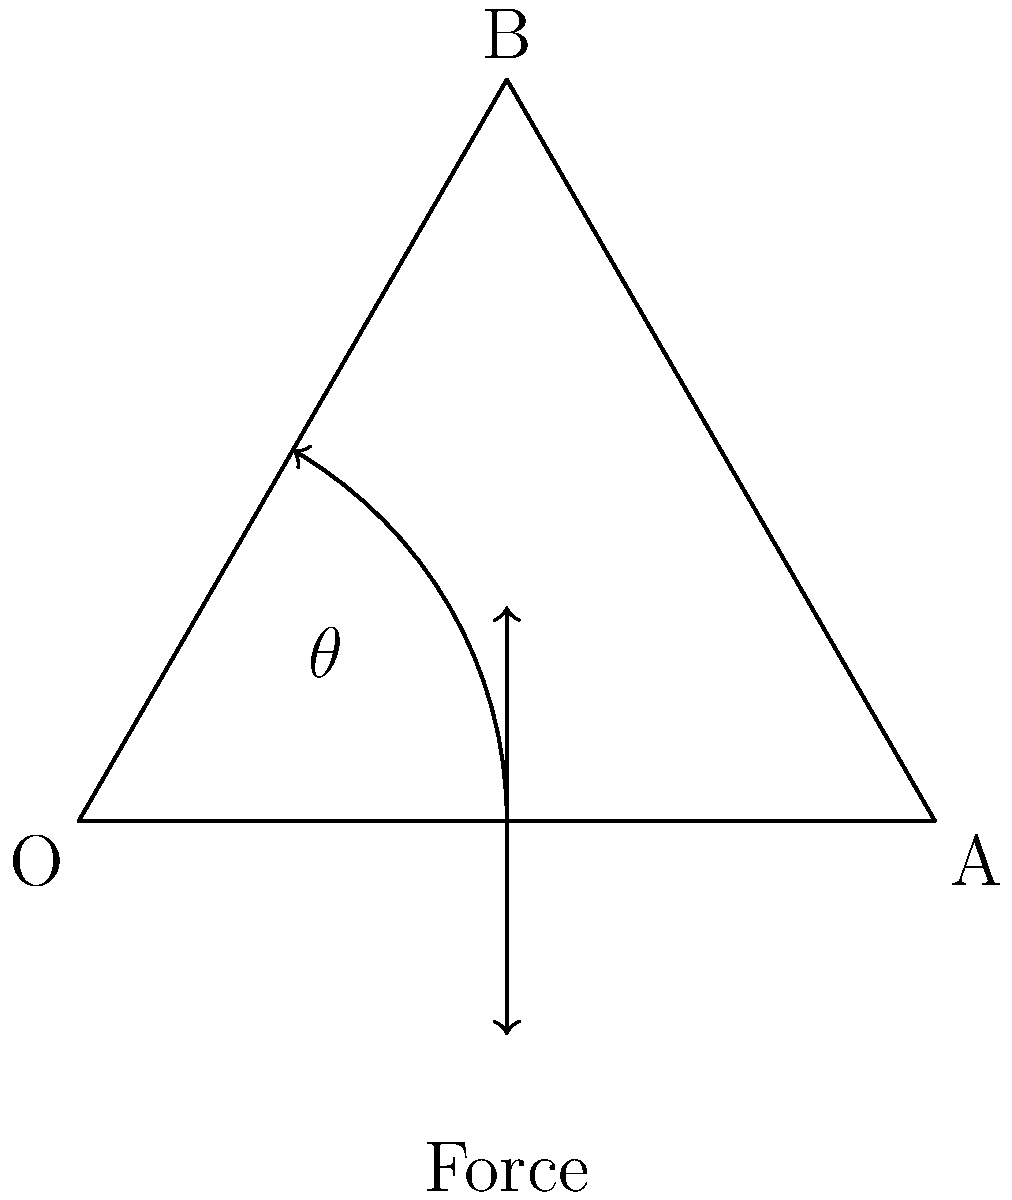During a knee extension exercise in physical therapy, the quadriceps muscle applies a force to extend the lower leg. If the angle of knee flexion ($\theta$) is 60°, and the quadriceps force is 100 N, what is the magnitude of the torque produced about the knee joint? Assume the distance from the knee joint center to the point of force application is 5 cm. To solve this problem, we'll follow these steps:

1. Recall the formula for torque:
   $$\tau = F \cdot r \cdot \sin(\theta)$$
   Where:
   $\tau$ = torque
   $F$ = force
   $r$ = distance from the axis of rotation to the point of force application
   $\theta$ = angle between the force vector and the lever arm

2. Identify the given values:
   $F = 100$ N
   $r = 5$ cm = 0.05 m
   $\theta = 60°$

3. Substitute these values into the torque equation:
   $$\tau = 100 \text{ N} \cdot 0.05 \text{ m} \cdot \sin(60°)$$

4. Calculate $\sin(60°)$:
   $$\sin(60°) = \frac{\sqrt{3}}{2} \approx 0.866$$

5. Substitute this value and calculate the torque:
   $$\tau = 100 \text{ N} \cdot 0.05 \text{ m} \cdot 0.866$$
   $$\tau = 4.33 \text{ N⋅m}$$

6. Round to two decimal places:
   $$\tau \approx 4.33 \text{ N⋅m}$$
Answer: 4.33 N⋅m 